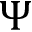<formula> <loc_0><loc_0><loc_500><loc_500>\Psi</formula> 